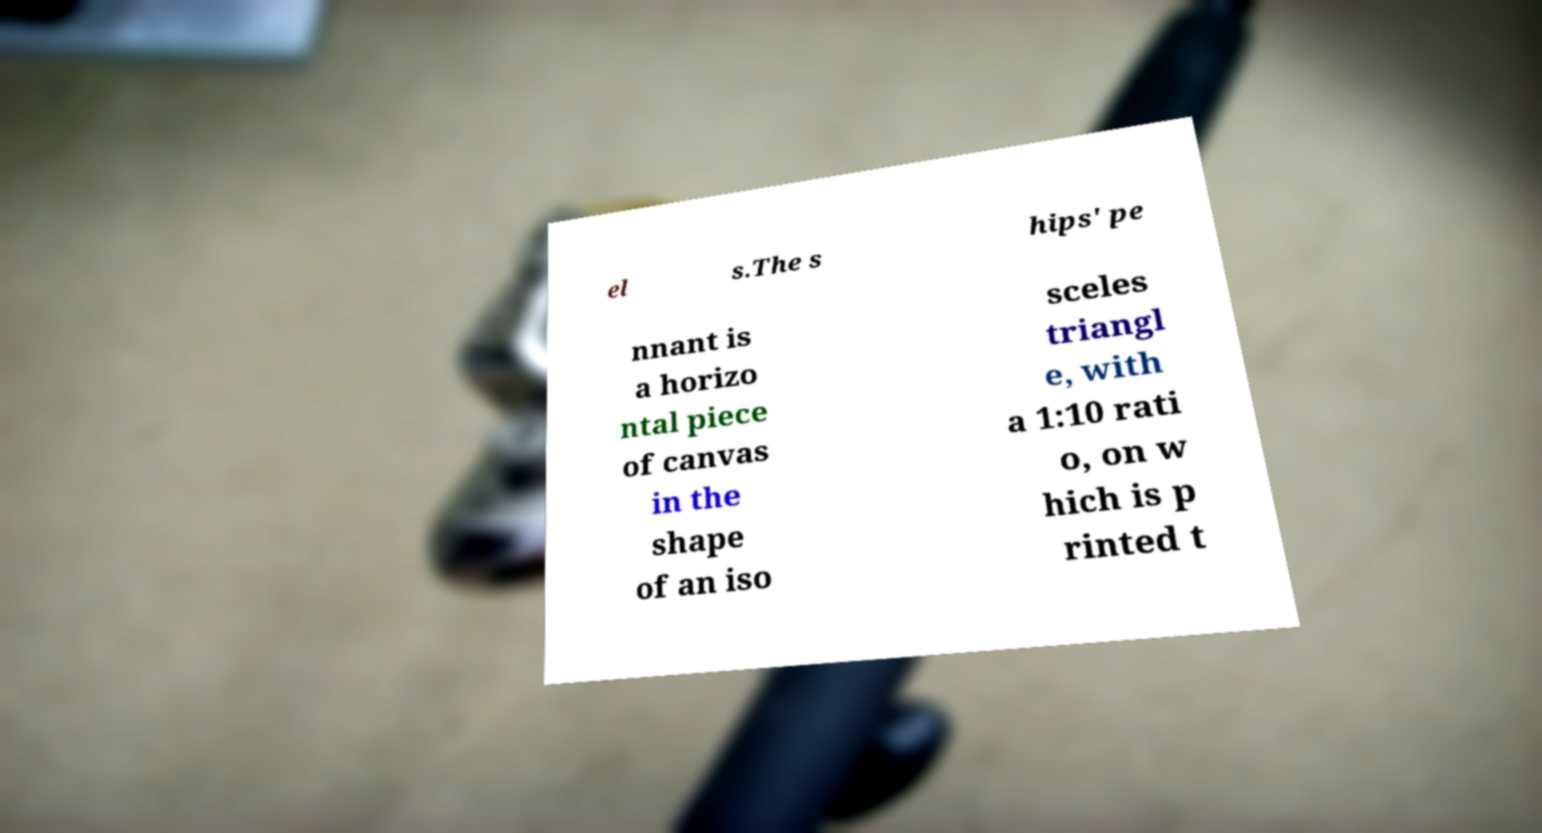Can you read and provide the text displayed in the image?This photo seems to have some interesting text. Can you extract and type it out for me? el s.The s hips' pe nnant is a horizo ntal piece of canvas in the shape of an iso sceles triangl e, with a 1:10 rati o, on w hich is p rinted t 